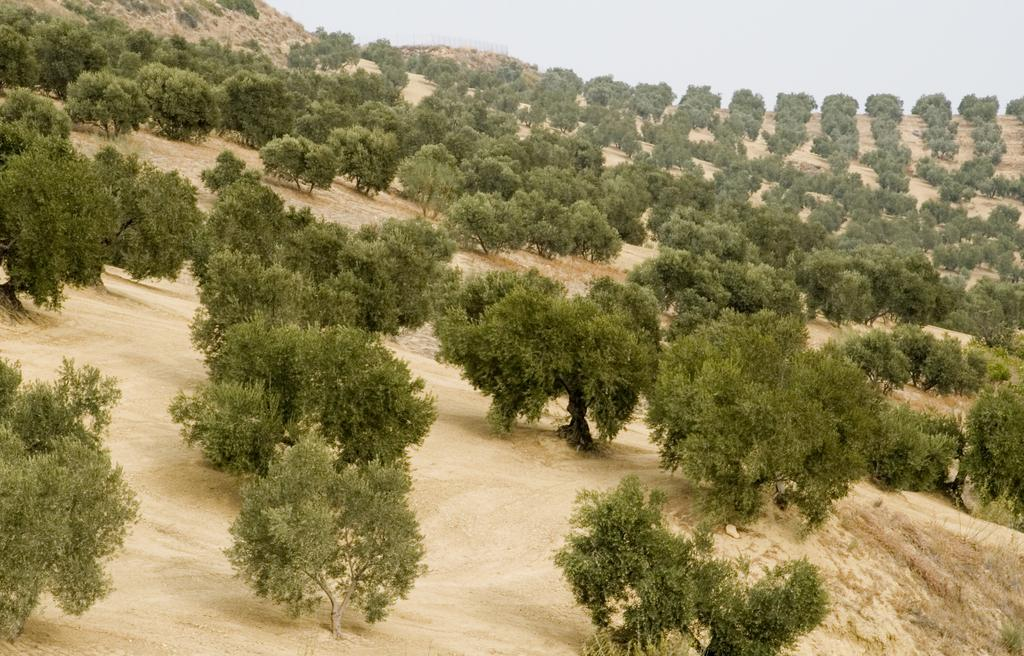What is the possible location of the image? The image might be taken on the top of a hill. What type of vegetation can be seen in the image? There are many trees in the image. What is the ground surface like in the image? There is grass visible in the image. What is visible at the top of the image? The sky is visible at the top of the image. Can you see any copper deposits in the image? There is no mention of copper deposits in the image, and therefore it cannot be determined if they are present. 